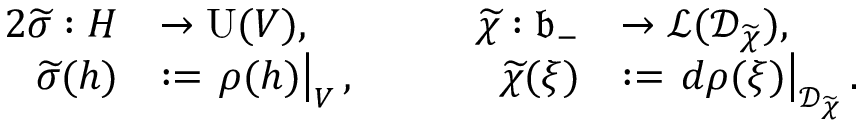Convert formula to latex. <formula><loc_0><loc_0><loc_500><loc_500>\begin{array} { r l r l } { { 2 } \widetilde { \sigma } \colon H } & { \to U ( V ) , } & { \quad \widetilde { \chi } \colon \mathfrak { b } _ { - } } & { \to \mathcal { L } ( \mathcal { D } _ { \widetilde { \chi } } ) , } \\ { \widetilde { \sigma } ( h ) } & { \colon = \rho ( h ) \right | _ { V } , } & { \widetilde { \chi } ( \xi ) } & { \colon = d \rho ( \xi ) \right | _ { \mathcal { D } _ { \widetilde { \chi } } } . } \end{array}</formula> 